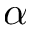<formula> <loc_0><loc_0><loc_500><loc_500>\alpha</formula> 